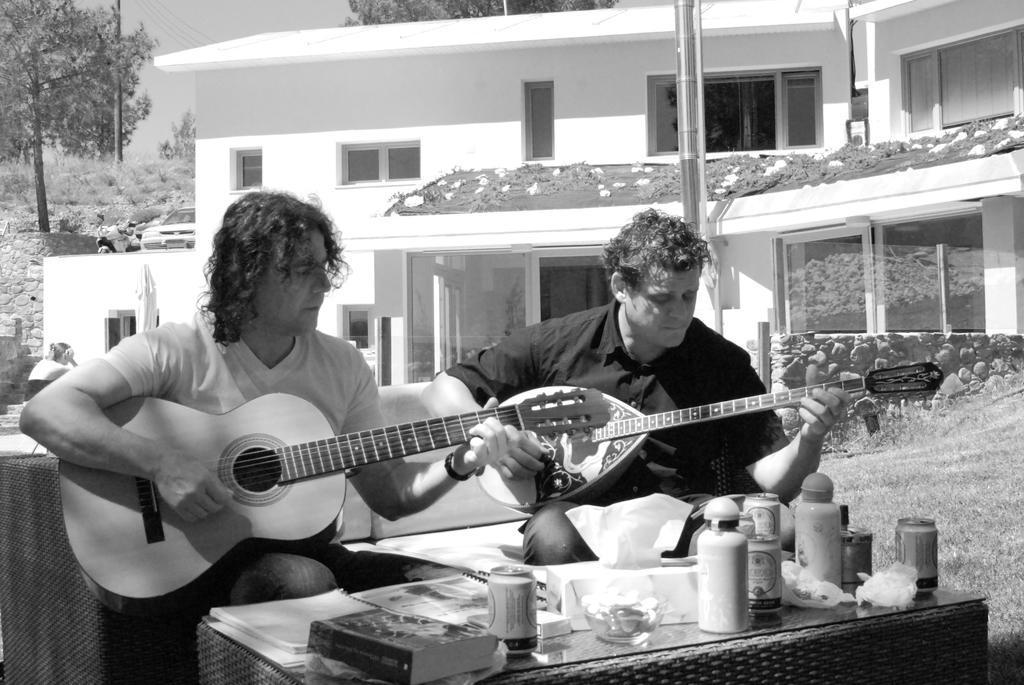How would you summarize this image in a sentence or two? In this picture two persons are seated on the chair, and their playing guitar, in front of them we can find couple of bottles, boxes on the table, in the background we can see a building, a pole, car and couple of trees. 